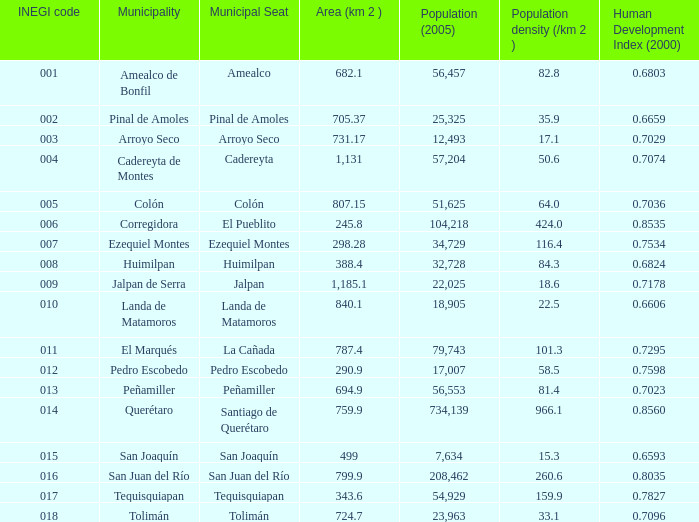What is the area in square kilometers with a 2005 population of 57,204 and a human development index from 2000 that is less than 0.7074? 0.0. 